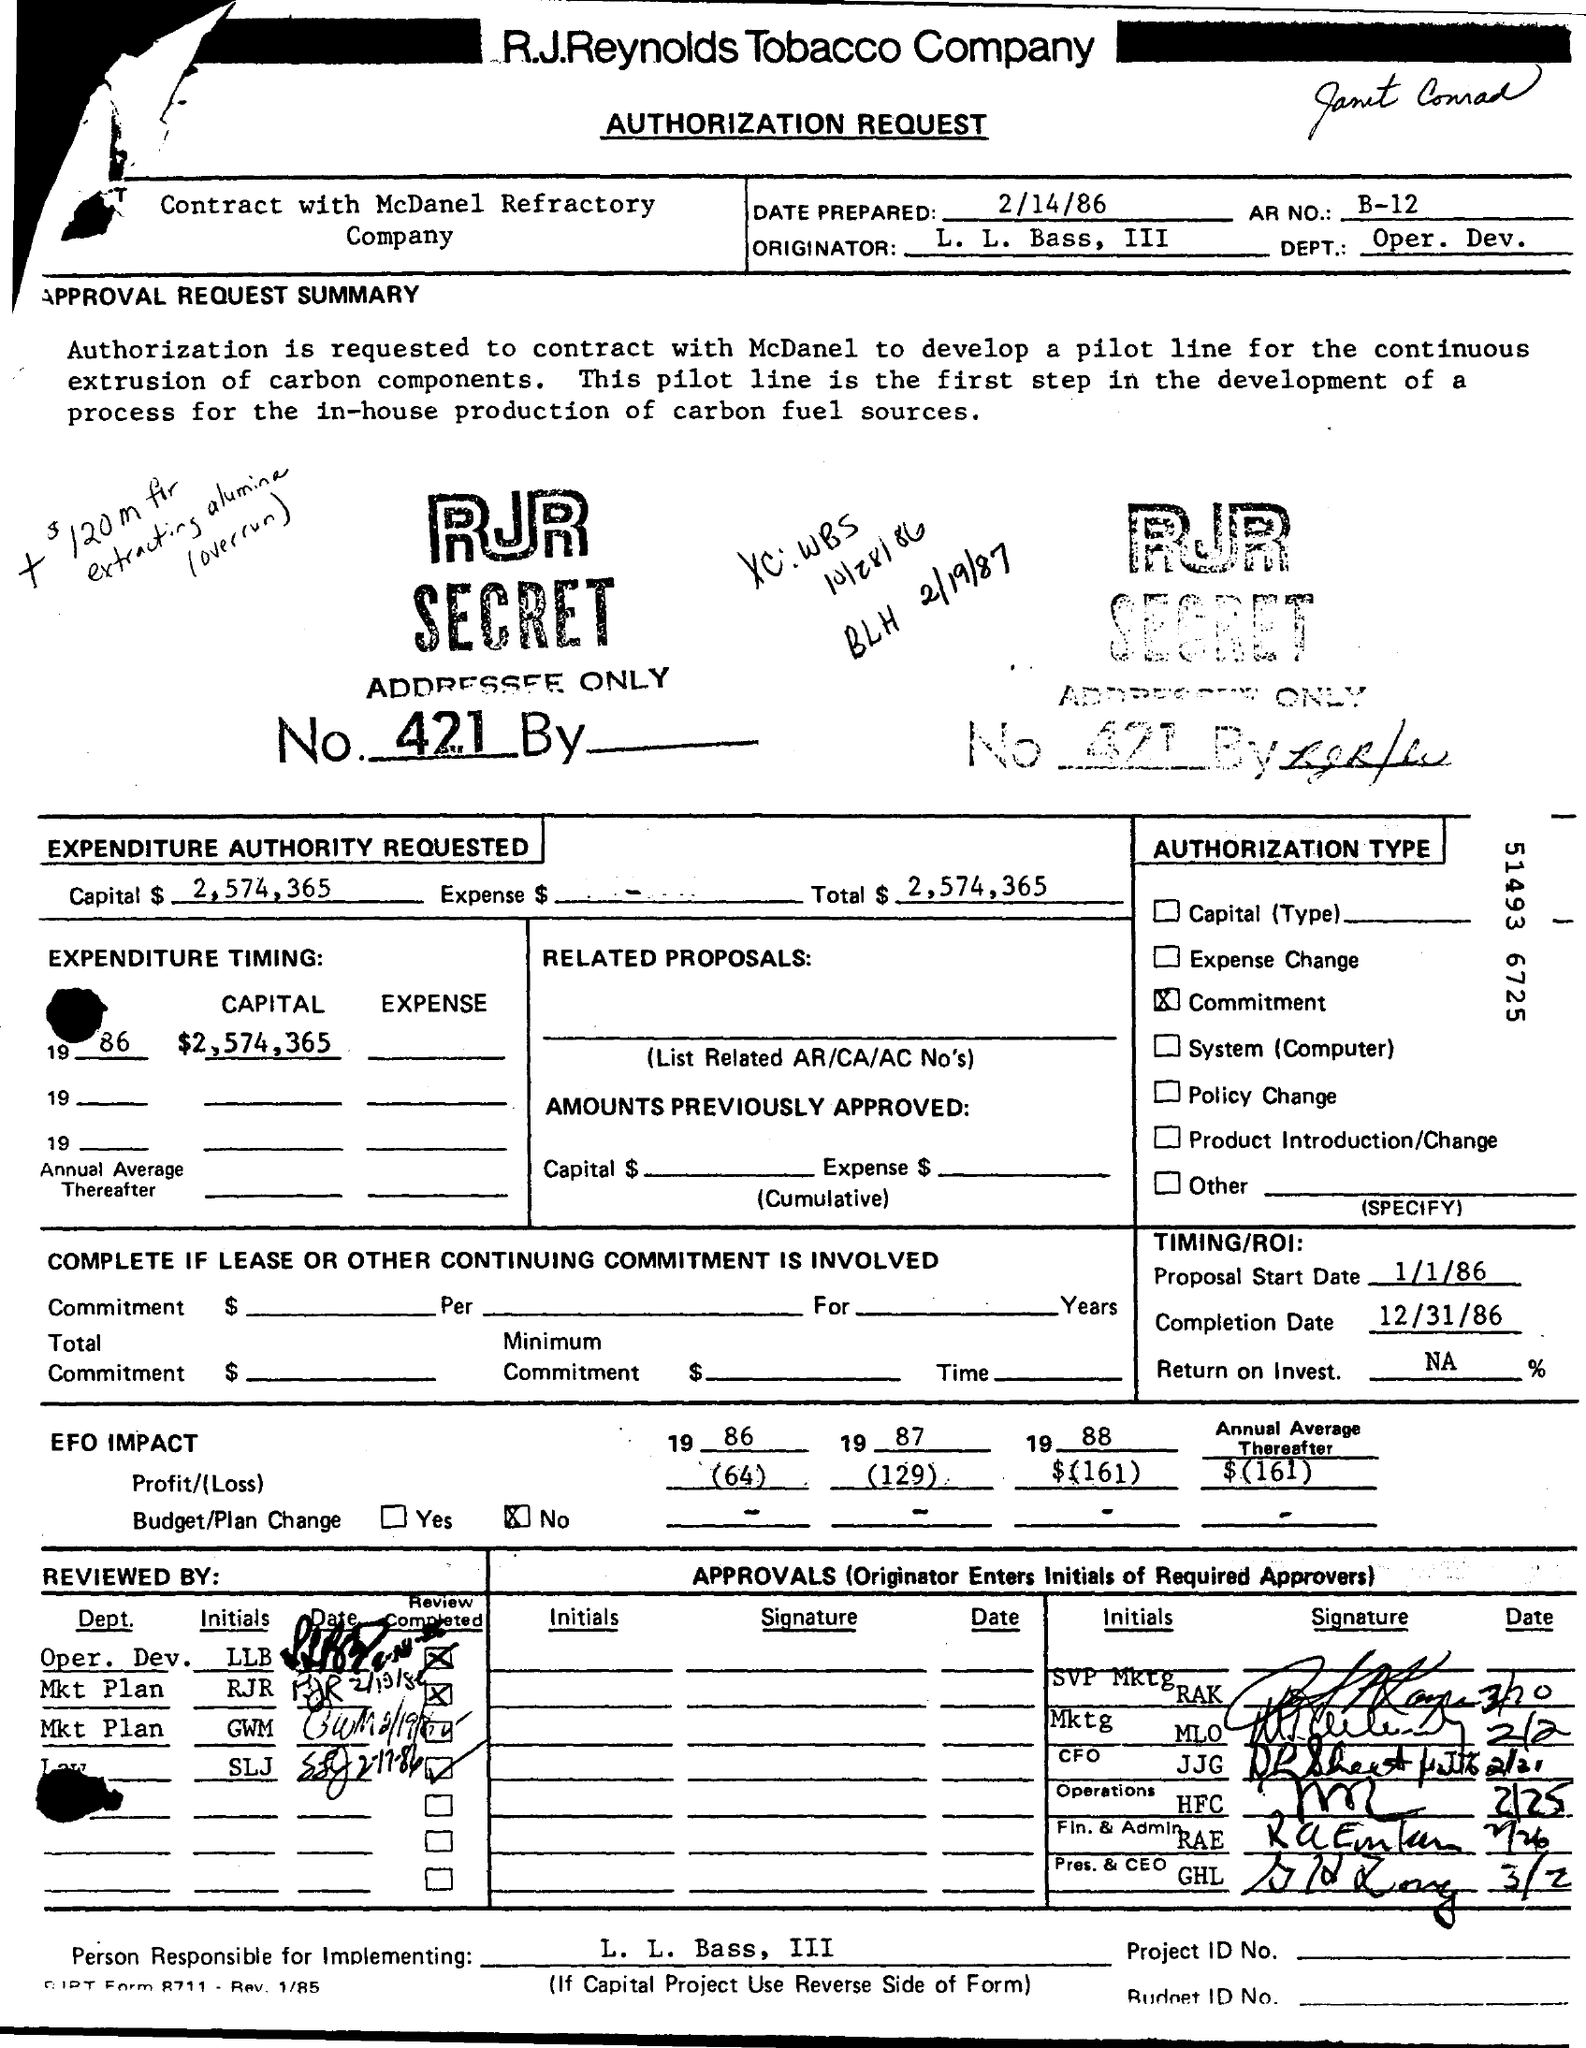What is the Completion Date?
 12/31/86 